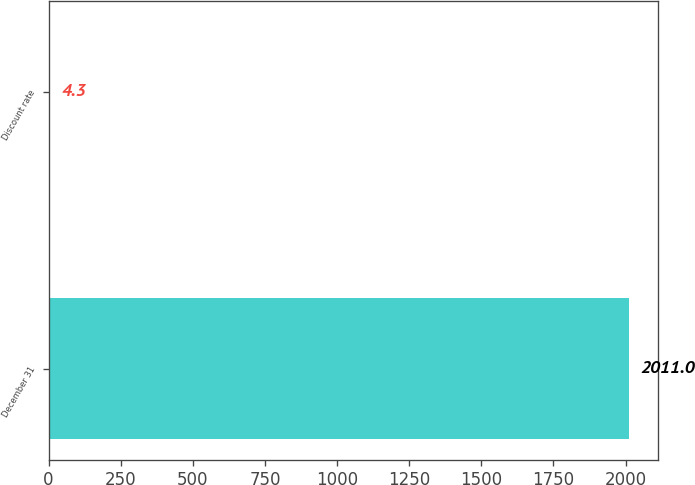Convert chart to OTSL. <chart><loc_0><loc_0><loc_500><loc_500><bar_chart><fcel>December 31<fcel>Discount rate<nl><fcel>2011<fcel>4.3<nl></chart> 